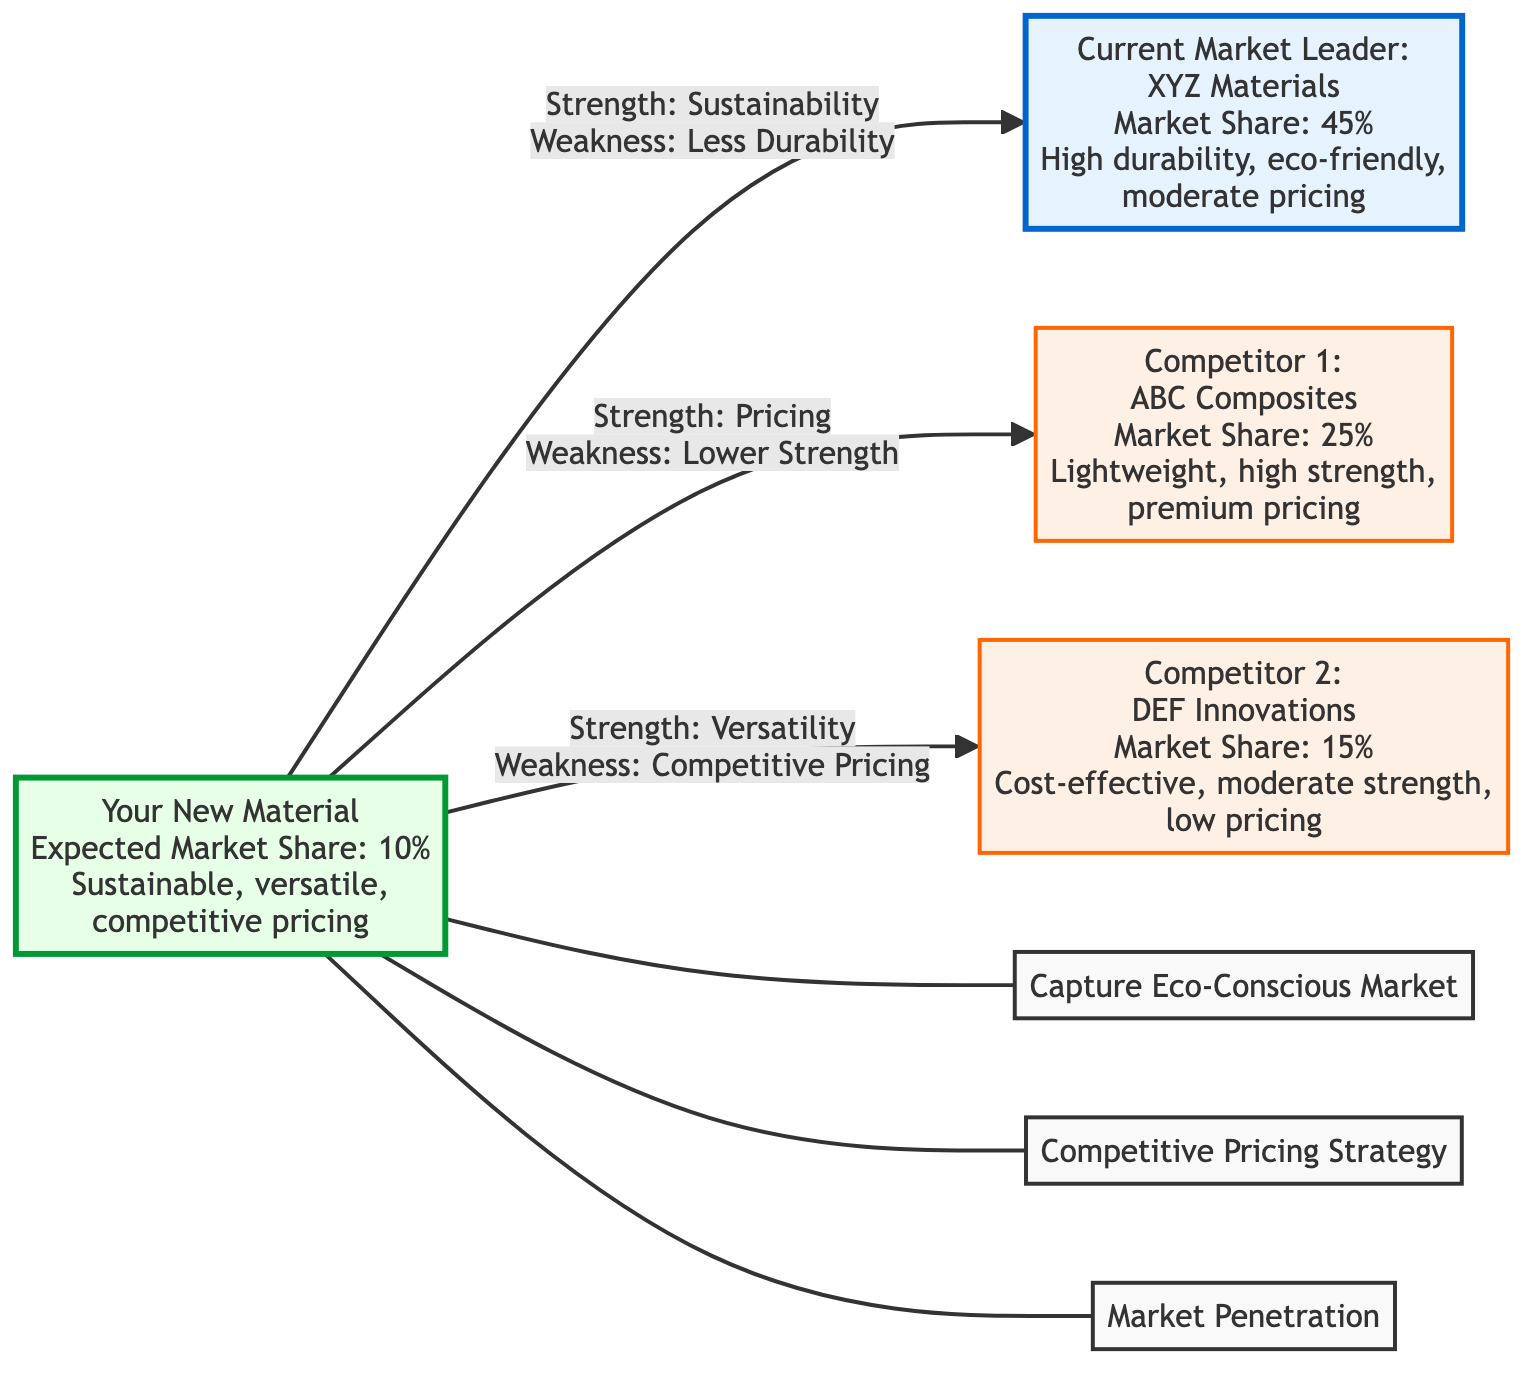What is the market share of the current market leader? The current market leader, represented by the node labeled "Current Market Leader: XYZ Materials," has a market share value of 45%, as clearly stated in the diagram.
Answer: 45% What is a strength of the new material? The strengths of the new material are listed in the diagram, with one key strength being sustainability, as indicated by the connection from the new material node to the market leader node.
Answer: Sustainability Which competitor has the highest market share? Among the competitors, the node labeled "Competitor 1: ABC Composites" shows a market share of 25%, while Competitor 2 has a lower market share of 15%. Therefore, Competitor 1 has the highest market share of the competitors.
Answer: ABC Composites What is the weakness of the new material relative to the current market leader? The diagram specifies that the new material has a weakness of less durability compared to the current market leader, indicated by a direct link from the new material to the market leader node which highlights this weakness.
Answer: Less Durability What positioning strategy targets eco-conscious consumers? The positioning strategy associated with the new material targeting eco-conscious consumers is labeled "Capture Eco-Conscious Market" in the diagram. This strategy is directly connected to the new material node.
Answer: Capture Eco-Conscious Market What is the market share of the new material? The diagram explicitly indicates that the new material is expected to achieve a market share of 10%, represented in the node labeled "Your New Material."
Answer: 10% Which material has a premium pricing strategy? The competitor that uses a premium pricing strategy is indicated in the diagram as "Competitor 1: ABC Composites," which clearly states this pricing strategy in its corresponding node.
Answer: ABC Composites Which competitor offers cost-effective solutions? The competitor that provides cost-effective solutions is labeled in the diagram as "Competitor 2: DEF Innovations," with a clear description under its node indicating this pricing strategy.
Answer: DEF Innovations What is a weakness of Competitor 1? To answer this, we need to look at the analysis of the new material’s position relative to Competitor 1. The new material node indicates a weakness compared to Competitor 1 based on lower strength. This shows that Competitor 1’s weakness is implicitly in lower versatility.
Answer: Lower Versatility 